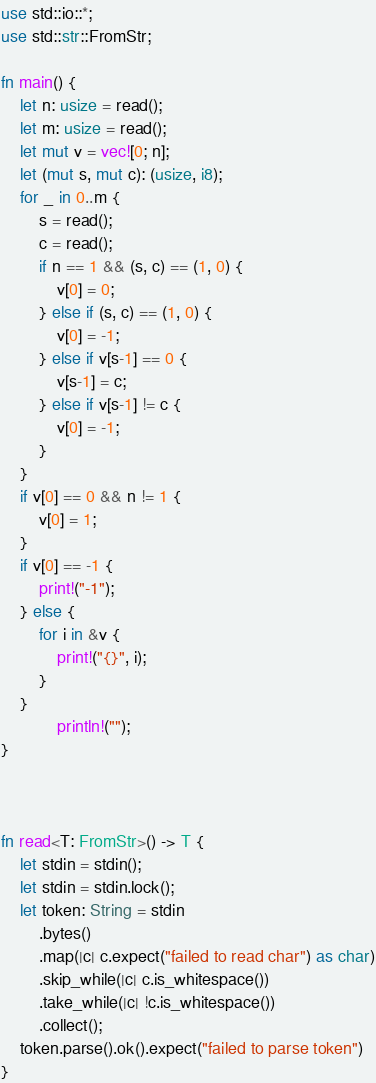Convert code to text. <code><loc_0><loc_0><loc_500><loc_500><_Rust_>use std::io::*;
use std::str::FromStr;

fn main() {
	let n: usize = read();
	let m: usize = read();
	let mut v = vec![0; n];
	let (mut s, mut c): (usize, i8);
	for _ in 0..m {
		s = read();
		c = read();
		if n == 1 && (s, c) == (1, 0) {
			v[0] = 0;
		} else if (s, c) == (1, 0) {
			v[0] = -1;
		} else if v[s-1] == 0 {
			v[s-1] = c;
		} else if v[s-1] != c {
			v[0] = -1;
		}
	}
	if v[0] == 0 && n != 1 {
		v[0] = 1;
	}
	if v[0] == -1 {
		print!("-1");
	} else {
		for i in &v {
			print!("{}", i);
		}
	}
			println!("");
}



fn read<T: FromStr>() -> T {
	let stdin = stdin();
	let stdin = stdin.lock();
	let token: String = stdin
		.bytes()
		.map(|c| c.expect("failed to read char") as char)
		.skip_while(|c| c.is_whitespace())
		.take_while(|c| !c.is_whitespace())
		.collect();
	token.parse().ok().expect("failed to parse token")
}

</code> 